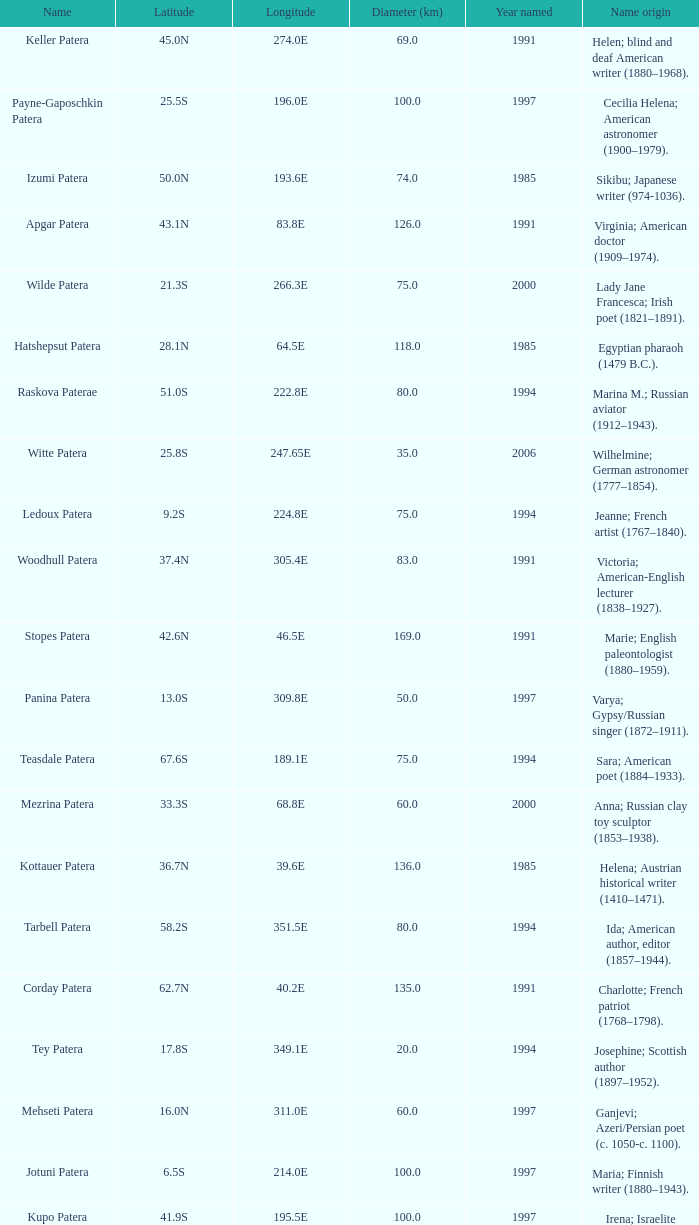What is the diameter in km of the feature named Colette Patera?  149.0. Parse the full table. {'header': ['Name', 'Latitude', 'Longitude', 'Diameter (km)', 'Year named', 'Name origin'], 'rows': [['Keller Patera', '45.0N', '274.0E', '69.0', '1991', 'Helen; blind and deaf American writer (1880–1968).'], ['Payne-Gaposchkin Patera', '25.5S', '196.0E', '100.0', '1997', 'Cecilia Helena; American astronomer (1900–1979).'], ['Izumi Patera', '50.0N', '193.6E', '74.0', '1985', 'Sikibu; Japanese writer (974-1036).'], ['Apgar Patera', '43.1N', '83.8E', '126.0', '1991', 'Virginia; American doctor (1909–1974).'], ['Wilde Patera', '21.3S', '266.3E', '75.0', '2000', 'Lady Jane Francesca; Irish poet (1821–1891).'], ['Hatshepsut Patera', '28.1N', '64.5E', '118.0', '1985', 'Egyptian pharaoh (1479 B.C.).'], ['Raskova Paterae', '51.0S', '222.8E', '80.0', '1994', 'Marina M.; Russian aviator (1912–1943).'], ['Witte Patera', '25.8S', '247.65E', '35.0', '2006', 'Wilhelmine; German astronomer (1777–1854).'], ['Ledoux Patera', '9.2S', '224.8E', '75.0', '1994', 'Jeanne; French artist (1767–1840).'], ['Woodhull Patera', '37.4N', '305.4E', '83.0', '1991', 'Victoria; American-English lecturer (1838–1927).'], ['Stopes Patera', '42.6N', '46.5E', '169.0', '1991', 'Marie; English paleontologist (1880–1959).'], ['Panina Patera', '13.0S', '309.8E', '50.0', '1997', 'Varya; Gypsy/Russian singer (1872–1911).'], ['Teasdale Patera', '67.6S', '189.1E', '75.0', '1994', 'Sara; American poet (1884–1933).'], ['Mezrina Patera', '33.3S', '68.8E', '60.0', '2000', 'Anna; Russian clay toy sculptor (1853–1938).'], ['Kottauer Patera', '36.7N', '39.6E', '136.0', '1985', 'Helena; Austrian historical writer (1410–1471).'], ['Tarbell Patera', '58.2S', '351.5E', '80.0', '1994', 'Ida; American author, editor (1857–1944).'], ['Corday Patera', '62.7N', '40.2E', '135.0', '1991', 'Charlotte; French patriot (1768–1798).'], ['Tey Patera', '17.8S', '349.1E', '20.0', '1994', 'Josephine; Scottish author (1897–1952).'], ['Mehseti Patera', '16.0N', '311.0E', '60.0', '1997', 'Ganjevi; Azeri/Persian poet (c. 1050-c. 1100).'], ['Jotuni Patera', '6.5S', '214.0E', '100.0', '1997', 'Maria; Finnish writer (1880–1943).'], ['Kupo Patera', '41.9S', '195.5E', '100.0', '1997', 'Irena; Israelite astronomer (1929–1978).'], ['Bakhtadze Patera', '45.5N', '219.5E', '50.0', '1997', 'Kseniya; Georgian tea genetist (1899–1978).'], ['Garland Patera', '32.7N', '206.8E', '45.0', '2006', 'Judy; American singer and actress (1922–1969).'], ['Siddons Patera', '61.6N', '340.6E', '47.0', '1997', 'Sarah; English actress (1755–1831).'], ['Hroswitha Patera', '35.8N', '34.8E', '163.0', '1985', 'German writer (c. A.D. 935-975).'], ['Pocahontas Patera', '64.9N', '49.4E', '78.0', '1991', 'Powhatan Indian peacemaker (1595–1617).'], ['Aitchison Patera', '16.7S', '349.4E', '28.0', '1994', 'Alison; American geographer.'], ['Carriera Patera', '48.6N', '48.8E', '97.0', '1991', 'Rosalba; Italian portrait painter (1675–1757).'], ['Lindgren Patera', '28.1N', '241.4E', '110.0', '2006', 'Astrid; Swedish author (1907–2002).'], ['Grizodubova Patera', '16.7N', '299.6E', '50.0', '1997', 'Valentina; Soviet aviatrix (1910–1993).'], ['Tipporah Patera', '38.9N', '43.0E', '99.0', '1985', 'Hebrew medical scholar (1500 B.C.).'], ['Bethune Patera', '46.5N', '321.3E', '94.0', '1991', 'Mary; American educator (1875–1955).'], ['Anning Paterae', '66.5N', '57.8E', '0.0', '1991', 'Mary; English paleontologist (1799–1847).'], ['Vibert-Douglas Patera', '11.6S', '194.3E', '45.0', '2003', 'Allie; Canadian astronomer (1894–1988).'], ['Colette Patera', '66.3N', '322.8E', '149.0', '1982', 'Claudine; French novelist (1873–1954).'], ['Darclée Patera', '37.4S', '263.8E', '15.0', '2006', 'Hariclea; Romanian soprano singer (1860–1939).'], ['Ayrton Patera', '6.0N', '227.3E', '85.0', '1994', 'Hertha M.; English physicist (1854–1923).'], ['Jaszai Patera', '32.0N', '305.0E', '70.0', '1997', 'Mary; Hungarian actress (1850–1926).'], ['Nordenflycht Patera', '35.0S', '266.0E', '140.0', '1997', 'Hedwig; Swedish poet (1718–1763).'], ['Anthony Patera', '48.2N', '32.6E', '70.0', '1991', 'Susan B.; American suffrage leader (1820–1906).'], ['Razia Patera', '46.2N', '197.8E', '157.0', '1985', 'Queen of Delhi Sultanate (India) (1236–1240).'], ['Shulzhenko Patera', '6.5N', '264.5E', '60.0', '1997', 'Klavdiya; Soviet singer (1906–1984).'], ['Villepreux-Power Patera', '22.0S', '210.0E', '100.0', '1997', 'Jeannette; French marine biologist (1794–1871).']]} 